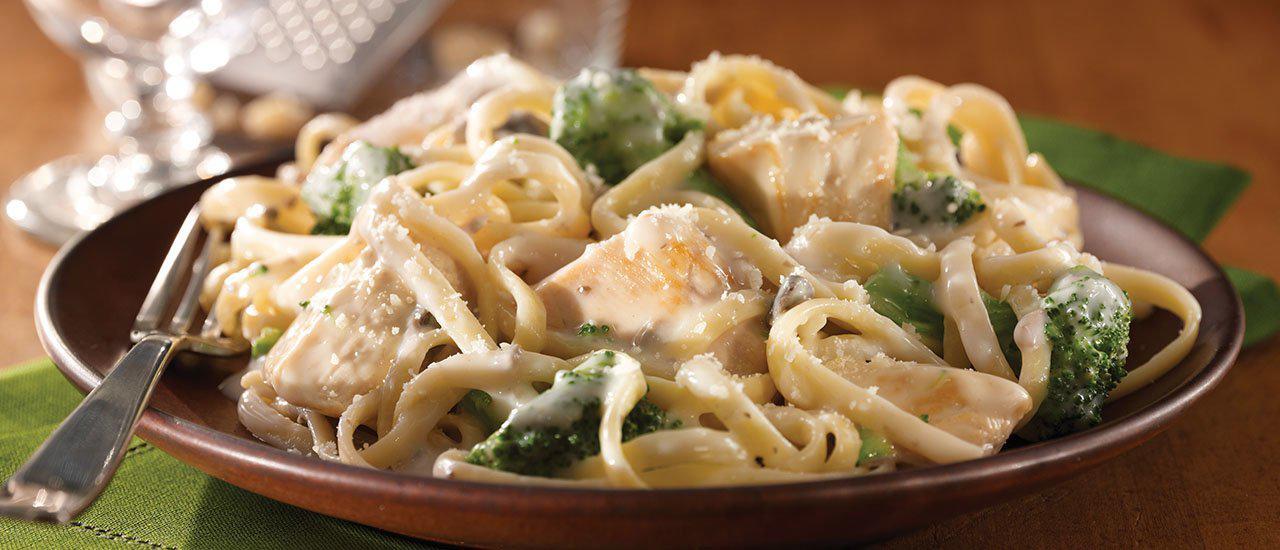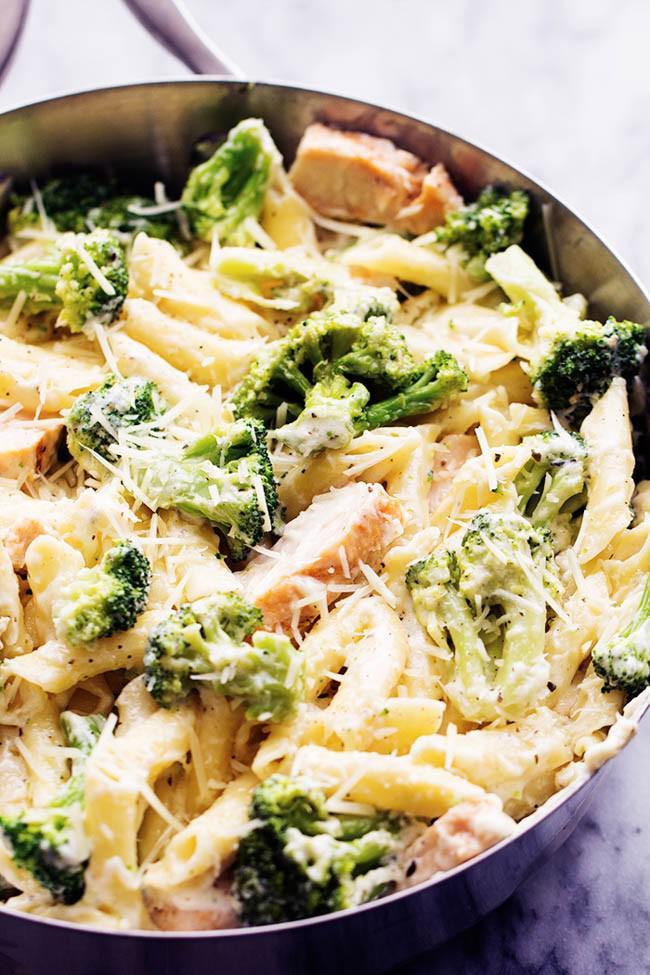The first image is the image on the left, the second image is the image on the right. Assess this claim about the two images: "A fork is resting on a plate of pasta in one image.". Correct or not? Answer yes or no. Yes. 